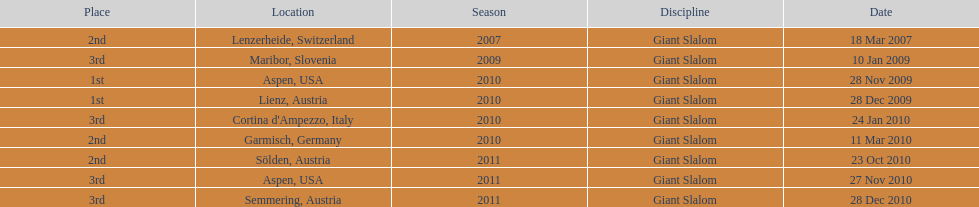Where was her first win? Aspen, USA. 